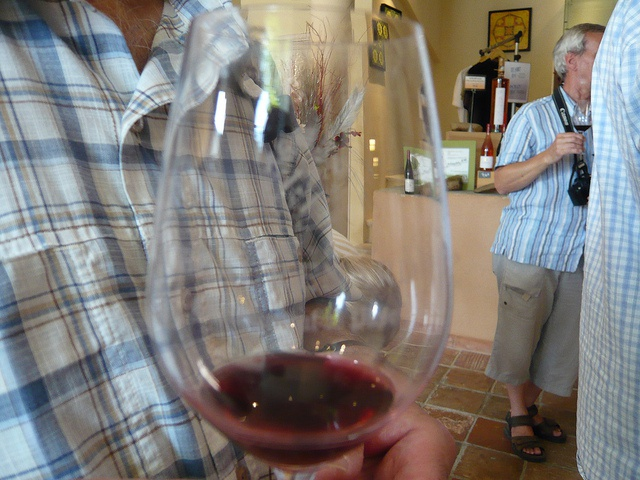Describe the objects in this image and their specific colors. I can see wine glass in black, darkgray, gray, and tan tones, people in black, gray, darkgray, and lightblue tones, people in black, gray, lightblue, and darkgray tones, people in black, darkgray, lightblue, and gray tones, and bottle in black, maroon, lightgray, and darkgray tones in this image. 